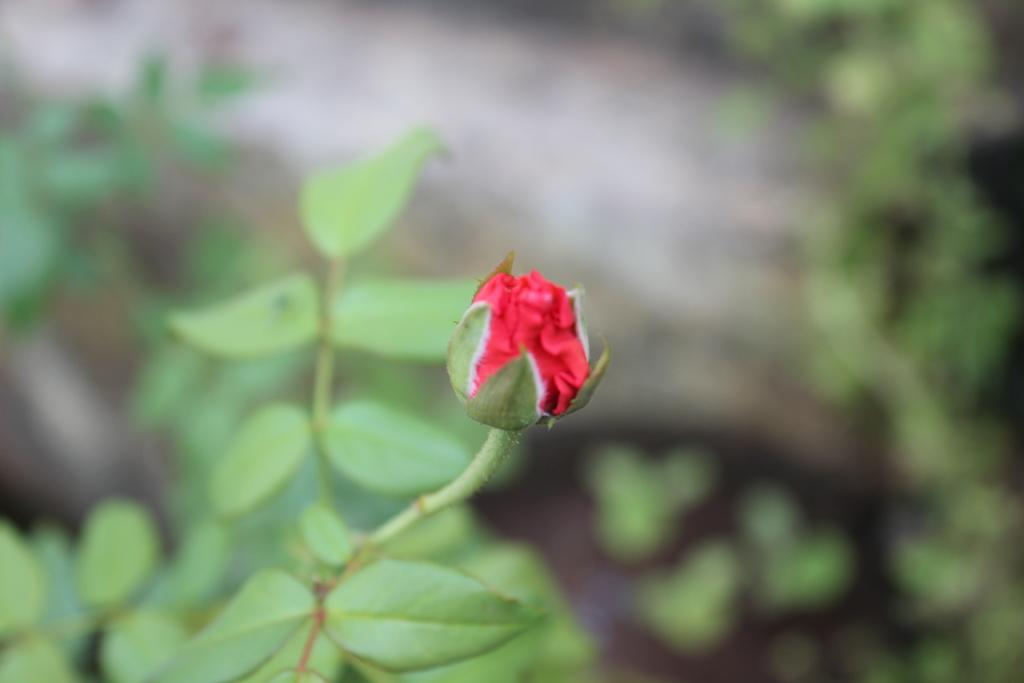What is present on the stem of the plant in the image? There is a bud on the stem of a plant in the image. What else can be seen in the image besides the bud? There are leaves visible in the image. What type of robin can be seen sitting on the sponge in the image? There is no robin or sponge present in the image; it only features a plant with a bud and leaves. What scientific theory is being demonstrated in the image? The image does not depict a scientific theory; it simply shows a plant with a bud and leaves. 